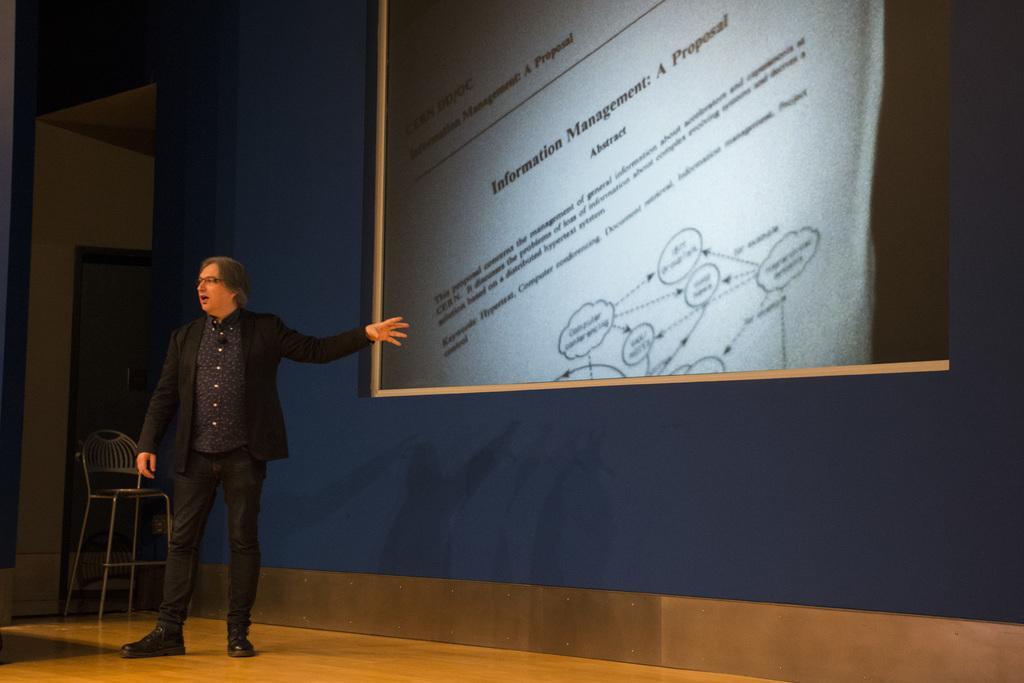Please provide a concise description of this image. In this picture I can see there is a man standing here and he is wearing a black blazer, and there is a chair in the backdrop and a screen and there is something displayed on the screen and there is a wall. 